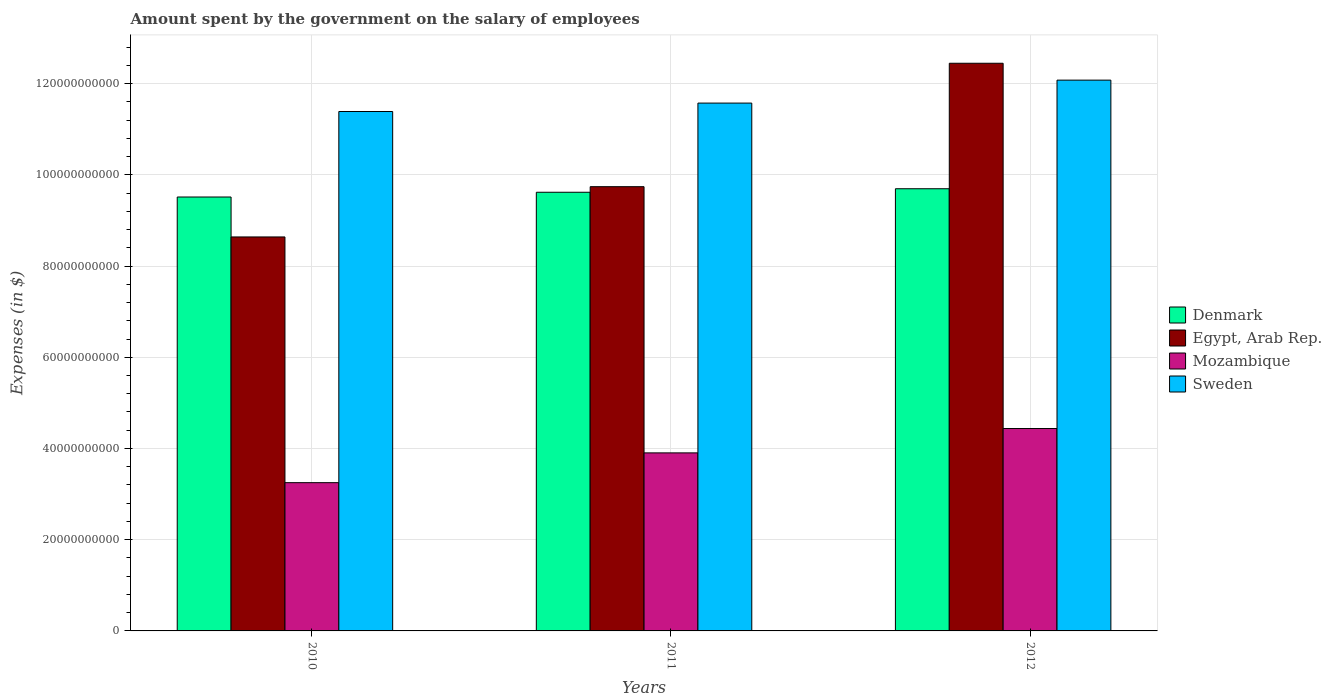How many different coloured bars are there?
Give a very brief answer. 4. Are the number of bars per tick equal to the number of legend labels?
Provide a short and direct response. Yes. How many bars are there on the 2nd tick from the right?
Your answer should be very brief. 4. What is the amount spent on the salary of employees by the government in Denmark in 2012?
Make the answer very short. 9.69e+1. Across all years, what is the maximum amount spent on the salary of employees by the government in Mozambique?
Your answer should be compact. 4.44e+1. Across all years, what is the minimum amount spent on the salary of employees by the government in Sweden?
Your answer should be compact. 1.14e+11. In which year was the amount spent on the salary of employees by the government in Egypt, Arab Rep. maximum?
Make the answer very short. 2012. What is the total amount spent on the salary of employees by the government in Egypt, Arab Rep. in the graph?
Provide a succinct answer. 3.08e+11. What is the difference between the amount spent on the salary of employees by the government in Mozambique in 2010 and that in 2011?
Your answer should be compact. -6.53e+09. What is the difference between the amount spent on the salary of employees by the government in Egypt, Arab Rep. in 2011 and the amount spent on the salary of employees by the government in Mozambique in 2010?
Ensure brevity in your answer.  6.49e+1. What is the average amount spent on the salary of employees by the government in Sweden per year?
Your answer should be compact. 1.17e+11. In the year 2011, what is the difference between the amount spent on the salary of employees by the government in Sweden and amount spent on the salary of employees by the government in Egypt, Arab Rep.?
Your answer should be compact. 1.83e+1. What is the ratio of the amount spent on the salary of employees by the government in Sweden in 2010 to that in 2011?
Offer a terse response. 0.98. Is the amount spent on the salary of employees by the government in Egypt, Arab Rep. in 2010 less than that in 2012?
Provide a short and direct response. Yes. Is the difference between the amount spent on the salary of employees by the government in Sweden in 2010 and 2012 greater than the difference between the amount spent on the salary of employees by the government in Egypt, Arab Rep. in 2010 and 2012?
Offer a very short reply. Yes. What is the difference between the highest and the second highest amount spent on the salary of employees by the government in Sweden?
Offer a terse response. 5.03e+09. What is the difference between the highest and the lowest amount spent on the salary of employees by the government in Sweden?
Your answer should be very brief. 6.88e+09. In how many years, is the amount spent on the salary of employees by the government in Denmark greater than the average amount spent on the salary of employees by the government in Denmark taken over all years?
Make the answer very short. 2. Is the sum of the amount spent on the salary of employees by the government in Denmark in 2010 and 2012 greater than the maximum amount spent on the salary of employees by the government in Mozambique across all years?
Offer a very short reply. Yes. Is it the case that in every year, the sum of the amount spent on the salary of employees by the government in Egypt, Arab Rep. and amount spent on the salary of employees by the government in Mozambique is greater than the sum of amount spent on the salary of employees by the government in Denmark and amount spent on the salary of employees by the government in Sweden?
Your answer should be very brief. No. What does the 4th bar from the right in 2011 represents?
Your answer should be very brief. Denmark. Is it the case that in every year, the sum of the amount spent on the salary of employees by the government in Denmark and amount spent on the salary of employees by the government in Egypt, Arab Rep. is greater than the amount spent on the salary of employees by the government in Mozambique?
Keep it short and to the point. Yes. What is the difference between two consecutive major ticks on the Y-axis?
Provide a short and direct response. 2.00e+1. Are the values on the major ticks of Y-axis written in scientific E-notation?
Your answer should be compact. No. Does the graph contain grids?
Keep it short and to the point. Yes. Where does the legend appear in the graph?
Keep it short and to the point. Center right. How many legend labels are there?
Provide a short and direct response. 4. What is the title of the graph?
Provide a succinct answer. Amount spent by the government on the salary of employees. What is the label or title of the Y-axis?
Give a very brief answer. Expenses (in $). What is the Expenses (in $) in Denmark in 2010?
Give a very brief answer. 9.51e+1. What is the Expenses (in $) in Egypt, Arab Rep. in 2010?
Your answer should be very brief. 8.64e+1. What is the Expenses (in $) in Mozambique in 2010?
Provide a succinct answer. 3.25e+1. What is the Expenses (in $) of Sweden in 2010?
Your answer should be compact. 1.14e+11. What is the Expenses (in $) of Denmark in 2011?
Ensure brevity in your answer.  9.62e+1. What is the Expenses (in $) in Egypt, Arab Rep. in 2011?
Make the answer very short. 9.74e+1. What is the Expenses (in $) in Mozambique in 2011?
Ensure brevity in your answer.  3.90e+1. What is the Expenses (in $) of Sweden in 2011?
Provide a short and direct response. 1.16e+11. What is the Expenses (in $) in Denmark in 2012?
Provide a succinct answer. 9.69e+1. What is the Expenses (in $) of Egypt, Arab Rep. in 2012?
Keep it short and to the point. 1.24e+11. What is the Expenses (in $) of Mozambique in 2012?
Your response must be concise. 4.44e+1. What is the Expenses (in $) in Sweden in 2012?
Make the answer very short. 1.21e+11. Across all years, what is the maximum Expenses (in $) of Denmark?
Ensure brevity in your answer.  9.69e+1. Across all years, what is the maximum Expenses (in $) in Egypt, Arab Rep.?
Make the answer very short. 1.24e+11. Across all years, what is the maximum Expenses (in $) of Mozambique?
Your answer should be very brief. 4.44e+1. Across all years, what is the maximum Expenses (in $) of Sweden?
Offer a terse response. 1.21e+11. Across all years, what is the minimum Expenses (in $) of Denmark?
Provide a short and direct response. 9.51e+1. Across all years, what is the minimum Expenses (in $) of Egypt, Arab Rep.?
Your answer should be compact. 8.64e+1. Across all years, what is the minimum Expenses (in $) in Mozambique?
Keep it short and to the point. 3.25e+1. Across all years, what is the minimum Expenses (in $) of Sweden?
Give a very brief answer. 1.14e+11. What is the total Expenses (in $) in Denmark in the graph?
Give a very brief answer. 2.88e+11. What is the total Expenses (in $) of Egypt, Arab Rep. in the graph?
Your answer should be compact. 3.08e+11. What is the total Expenses (in $) in Mozambique in the graph?
Make the answer very short. 1.16e+11. What is the total Expenses (in $) in Sweden in the graph?
Your answer should be very brief. 3.50e+11. What is the difference between the Expenses (in $) in Denmark in 2010 and that in 2011?
Provide a succinct answer. -1.04e+09. What is the difference between the Expenses (in $) in Egypt, Arab Rep. in 2010 and that in 2011?
Your answer should be compact. -1.10e+1. What is the difference between the Expenses (in $) of Mozambique in 2010 and that in 2011?
Keep it short and to the point. -6.53e+09. What is the difference between the Expenses (in $) in Sweden in 2010 and that in 2011?
Provide a succinct answer. -1.85e+09. What is the difference between the Expenses (in $) of Denmark in 2010 and that in 2012?
Keep it short and to the point. -1.81e+09. What is the difference between the Expenses (in $) in Egypt, Arab Rep. in 2010 and that in 2012?
Your answer should be very brief. -3.81e+1. What is the difference between the Expenses (in $) in Mozambique in 2010 and that in 2012?
Give a very brief answer. -1.19e+1. What is the difference between the Expenses (in $) of Sweden in 2010 and that in 2012?
Your answer should be compact. -6.88e+09. What is the difference between the Expenses (in $) of Denmark in 2011 and that in 2012?
Offer a terse response. -7.71e+08. What is the difference between the Expenses (in $) of Egypt, Arab Rep. in 2011 and that in 2012?
Keep it short and to the point. -2.71e+1. What is the difference between the Expenses (in $) of Mozambique in 2011 and that in 2012?
Ensure brevity in your answer.  -5.34e+09. What is the difference between the Expenses (in $) of Sweden in 2011 and that in 2012?
Give a very brief answer. -5.03e+09. What is the difference between the Expenses (in $) in Denmark in 2010 and the Expenses (in $) in Egypt, Arab Rep. in 2011?
Provide a short and direct response. -2.26e+09. What is the difference between the Expenses (in $) in Denmark in 2010 and the Expenses (in $) in Mozambique in 2011?
Provide a short and direct response. 5.61e+1. What is the difference between the Expenses (in $) of Denmark in 2010 and the Expenses (in $) of Sweden in 2011?
Your answer should be very brief. -2.06e+1. What is the difference between the Expenses (in $) in Egypt, Arab Rep. in 2010 and the Expenses (in $) in Mozambique in 2011?
Give a very brief answer. 4.73e+1. What is the difference between the Expenses (in $) of Egypt, Arab Rep. in 2010 and the Expenses (in $) of Sweden in 2011?
Provide a succinct answer. -2.93e+1. What is the difference between the Expenses (in $) in Mozambique in 2010 and the Expenses (in $) in Sweden in 2011?
Your answer should be very brief. -8.32e+1. What is the difference between the Expenses (in $) of Denmark in 2010 and the Expenses (in $) of Egypt, Arab Rep. in 2012?
Keep it short and to the point. -2.93e+1. What is the difference between the Expenses (in $) of Denmark in 2010 and the Expenses (in $) of Mozambique in 2012?
Your answer should be very brief. 5.08e+1. What is the difference between the Expenses (in $) of Denmark in 2010 and the Expenses (in $) of Sweden in 2012?
Ensure brevity in your answer.  -2.56e+1. What is the difference between the Expenses (in $) of Egypt, Arab Rep. in 2010 and the Expenses (in $) of Mozambique in 2012?
Your answer should be very brief. 4.20e+1. What is the difference between the Expenses (in $) of Egypt, Arab Rep. in 2010 and the Expenses (in $) of Sweden in 2012?
Ensure brevity in your answer.  -3.44e+1. What is the difference between the Expenses (in $) in Mozambique in 2010 and the Expenses (in $) in Sweden in 2012?
Provide a short and direct response. -8.83e+1. What is the difference between the Expenses (in $) in Denmark in 2011 and the Expenses (in $) in Egypt, Arab Rep. in 2012?
Offer a terse response. -2.83e+1. What is the difference between the Expenses (in $) in Denmark in 2011 and the Expenses (in $) in Mozambique in 2012?
Provide a succinct answer. 5.18e+1. What is the difference between the Expenses (in $) in Denmark in 2011 and the Expenses (in $) in Sweden in 2012?
Give a very brief answer. -2.46e+1. What is the difference between the Expenses (in $) of Egypt, Arab Rep. in 2011 and the Expenses (in $) of Mozambique in 2012?
Your answer should be very brief. 5.30e+1. What is the difference between the Expenses (in $) of Egypt, Arab Rep. in 2011 and the Expenses (in $) of Sweden in 2012?
Make the answer very short. -2.34e+1. What is the difference between the Expenses (in $) in Mozambique in 2011 and the Expenses (in $) in Sweden in 2012?
Your answer should be compact. -8.17e+1. What is the average Expenses (in $) in Denmark per year?
Keep it short and to the point. 9.61e+1. What is the average Expenses (in $) of Egypt, Arab Rep. per year?
Your response must be concise. 1.03e+11. What is the average Expenses (in $) in Mozambique per year?
Your answer should be compact. 3.86e+1. What is the average Expenses (in $) of Sweden per year?
Give a very brief answer. 1.17e+11. In the year 2010, what is the difference between the Expenses (in $) in Denmark and Expenses (in $) in Egypt, Arab Rep.?
Give a very brief answer. 8.76e+09. In the year 2010, what is the difference between the Expenses (in $) in Denmark and Expenses (in $) in Mozambique?
Make the answer very short. 6.26e+1. In the year 2010, what is the difference between the Expenses (in $) of Denmark and Expenses (in $) of Sweden?
Make the answer very short. -1.87e+1. In the year 2010, what is the difference between the Expenses (in $) in Egypt, Arab Rep. and Expenses (in $) in Mozambique?
Your answer should be very brief. 5.39e+1. In the year 2010, what is the difference between the Expenses (in $) in Egypt, Arab Rep. and Expenses (in $) in Sweden?
Keep it short and to the point. -2.75e+1. In the year 2010, what is the difference between the Expenses (in $) in Mozambique and Expenses (in $) in Sweden?
Provide a short and direct response. -8.14e+1. In the year 2011, what is the difference between the Expenses (in $) of Denmark and Expenses (in $) of Egypt, Arab Rep.?
Provide a succinct answer. -1.22e+09. In the year 2011, what is the difference between the Expenses (in $) of Denmark and Expenses (in $) of Mozambique?
Ensure brevity in your answer.  5.71e+1. In the year 2011, what is the difference between the Expenses (in $) of Denmark and Expenses (in $) of Sweden?
Provide a succinct answer. -1.95e+1. In the year 2011, what is the difference between the Expenses (in $) of Egypt, Arab Rep. and Expenses (in $) of Mozambique?
Offer a terse response. 5.84e+1. In the year 2011, what is the difference between the Expenses (in $) of Egypt, Arab Rep. and Expenses (in $) of Sweden?
Give a very brief answer. -1.83e+1. In the year 2011, what is the difference between the Expenses (in $) in Mozambique and Expenses (in $) in Sweden?
Your response must be concise. -7.67e+1. In the year 2012, what is the difference between the Expenses (in $) in Denmark and Expenses (in $) in Egypt, Arab Rep.?
Offer a very short reply. -2.75e+1. In the year 2012, what is the difference between the Expenses (in $) in Denmark and Expenses (in $) in Mozambique?
Offer a terse response. 5.26e+1. In the year 2012, what is the difference between the Expenses (in $) of Denmark and Expenses (in $) of Sweden?
Keep it short and to the point. -2.38e+1. In the year 2012, what is the difference between the Expenses (in $) in Egypt, Arab Rep. and Expenses (in $) in Mozambique?
Provide a short and direct response. 8.01e+1. In the year 2012, what is the difference between the Expenses (in $) in Egypt, Arab Rep. and Expenses (in $) in Sweden?
Your answer should be compact. 3.70e+09. In the year 2012, what is the difference between the Expenses (in $) in Mozambique and Expenses (in $) in Sweden?
Provide a short and direct response. -7.64e+1. What is the ratio of the Expenses (in $) in Denmark in 2010 to that in 2011?
Keep it short and to the point. 0.99. What is the ratio of the Expenses (in $) of Egypt, Arab Rep. in 2010 to that in 2011?
Give a very brief answer. 0.89. What is the ratio of the Expenses (in $) in Mozambique in 2010 to that in 2011?
Your answer should be compact. 0.83. What is the ratio of the Expenses (in $) of Sweden in 2010 to that in 2011?
Your answer should be very brief. 0.98. What is the ratio of the Expenses (in $) in Denmark in 2010 to that in 2012?
Make the answer very short. 0.98. What is the ratio of the Expenses (in $) in Egypt, Arab Rep. in 2010 to that in 2012?
Your answer should be very brief. 0.69. What is the ratio of the Expenses (in $) in Mozambique in 2010 to that in 2012?
Provide a succinct answer. 0.73. What is the ratio of the Expenses (in $) of Sweden in 2010 to that in 2012?
Provide a succinct answer. 0.94. What is the ratio of the Expenses (in $) in Egypt, Arab Rep. in 2011 to that in 2012?
Make the answer very short. 0.78. What is the ratio of the Expenses (in $) of Mozambique in 2011 to that in 2012?
Provide a succinct answer. 0.88. What is the difference between the highest and the second highest Expenses (in $) of Denmark?
Provide a short and direct response. 7.71e+08. What is the difference between the highest and the second highest Expenses (in $) in Egypt, Arab Rep.?
Provide a succinct answer. 2.71e+1. What is the difference between the highest and the second highest Expenses (in $) in Mozambique?
Your answer should be compact. 5.34e+09. What is the difference between the highest and the second highest Expenses (in $) of Sweden?
Offer a very short reply. 5.03e+09. What is the difference between the highest and the lowest Expenses (in $) of Denmark?
Make the answer very short. 1.81e+09. What is the difference between the highest and the lowest Expenses (in $) in Egypt, Arab Rep.?
Ensure brevity in your answer.  3.81e+1. What is the difference between the highest and the lowest Expenses (in $) of Mozambique?
Make the answer very short. 1.19e+1. What is the difference between the highest and the lowest Expenses (in $) in Sweden?
Ensure brevity in your answer.  6.88e+09. 